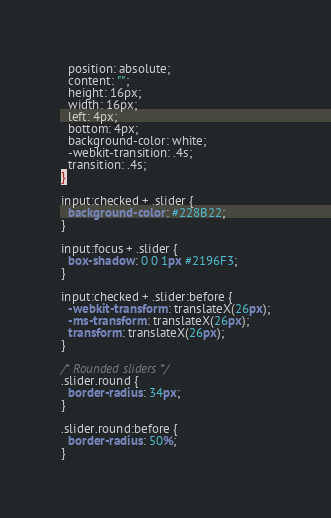<code> <loc_0><loc_0><loc_500><loc_500><_CSS_>  position: absolute;
  content: "";
  height: 16px;
  width: 16px;
  left: 4px;
  bottom: 4px;
  background-color: white;
  -webkit-transition: .4s;
  transition: .4s;
}

input:checked + .slider {
  background-color: #228B22;
}

input:focus + .slider {
  box-shadow: 0 0 1px #2196F3;
}

input:checked + .slider:before {
  -webkit-transform: translateX(26px);
  -ms-transform: translateX(26px);
  transform: translateX(26px);
}

/* Rounded sliders */
.slider.round {
  border-radius: 34px;
}

.slider.round:before {
  border-radius: 50%;
}</code> 